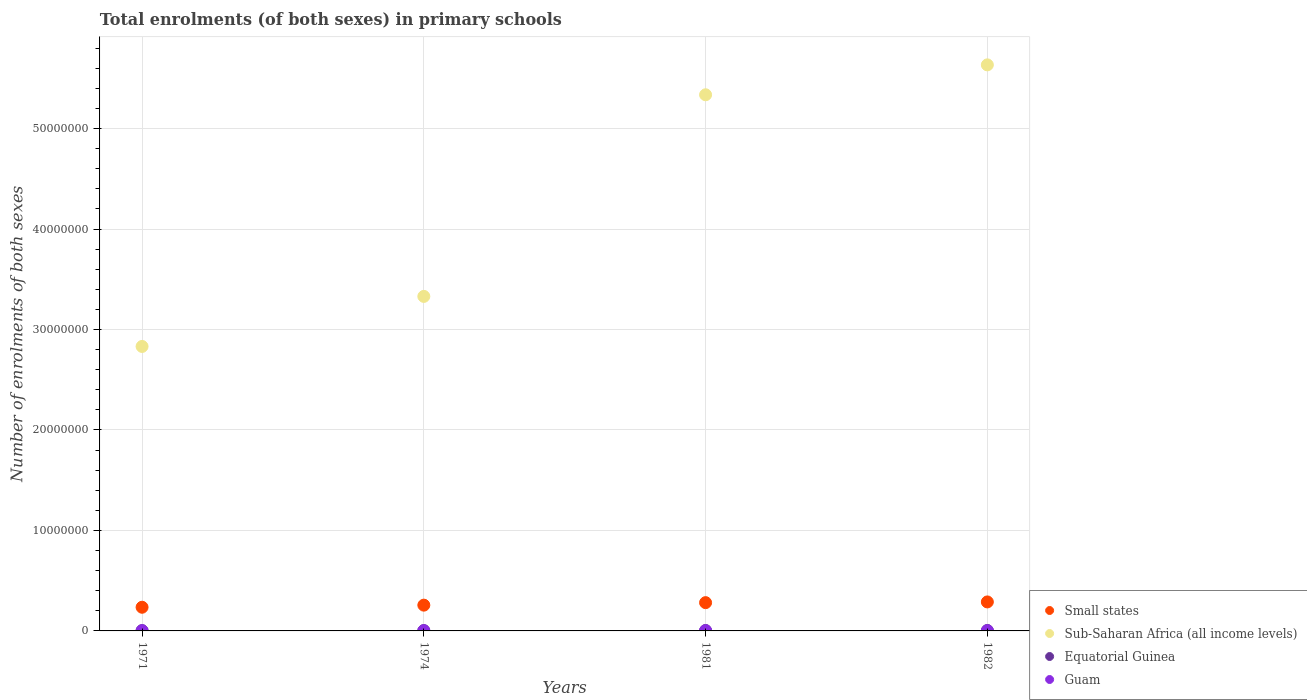How many different coloured dotlines are there?
Offer a terse response. 4. What is the number of enrolments in primary schools in Equatorial Guinea in 1971?
Your answer should be compact. 3.16e+04. Across all years, what is the maximum number of enrolments in primary schools in Guam?
Your answer should be compact. 1.85e+04. Across all years, what is the minimum number of enrolments in primary schools in Small states?
Offer a very short reply. 2.36e+06. In which year was the number of enrolments in primary schools in Equatorial Guinea maximum?
Provide a short and direct response. 1982. In which year was the number of enrolments in primary schools in Small states minimum?
Offer a very short reply. 1971. What is the total number of enrolments in primary schools in Small states in the graph?
Offer a very short reply. 1.06e+07. What is the difference between the number of enrolments in primary schools in Small states in 1971 and that in 1981?
Your response must be concise. -4.58e+05. What is the difference between the number of enrolments in primary schools in Sub-Saharan Africa (all income levels) in 1971 and the number of enrolments in primary schools in Guam in 1981?
Your answer should be compact. 2.83e+07. What is the average number of enrolments in primary schools in Sub-Saharan Africa (all income levels) per year?
Make the answer very short. 4.28e+07. In the year 1981, what is the difference between the number of enrolments in primary schools in Guam and number of enrolments in primary schools in Sub-Saharan Africa (all income levels)?
Ensure brevity in your answer.  -5.33e+07. In how many years, is the number of enrolments in primary schools in Sub-Saharan Africa (all income levels) greater than 22000000?
Your answer should be compact. 4. What is the ratio of the number of enrolments in primary schools in Equatorial Guinea in 1971 to that in 1981?
Keep it short and to the point. 0.71. Is the number of enrolments in primary schools in Guam in 1971 less than that in 1974?
Your answer should be very brief. Yes. Is the difference between the number of enrolments in primary schools in Guam in 1981 and 1982 greater than the difference between the number of enrolments in primary schools in Sub-Saharan Africa (all income levels) in 1981 and 1982?
Provide a succinct answer. Yes. What is the difference between the highest and the second highest number of enrolments in primary schools in Sub-Saharan Africa (all income levels)?
Your response must be concise. 2.98e+06. What is the difference between the highest and the lowest number of enrolments in primary schools in Small states?
Keep it short and to the point. 5.30e+05. Is the sum of the number of enrolments in primary schools in Equatorial Guinea in 1971 and 1982 greater than the maximum number of enrolments in primary schools in Small states across all years?
Keep it short and to the point. No. Is it the case that in every year, the sum of the number of enrolments in primary schools in Guam and number of enrolments in primary schools in Equatorial Guinea  is greater than the sum of number of enrolments in primary schools in Small states and number of enrolments in primary schools in Sub-Saharan Africa (all income levels)?
Ensure brevity in your answer.  No. Is it the case that in every year, the sum of the number of enrolments in primary schools in Sub-Saharan Africa (all income levels) and number of enrolments in primary schools in Equatorial Guinea  is greater than the number of enrolments in primary schools in Guam?
Your answer should be compact. Yes. Does the number of enrolments in primary schools in Guam monotonically increase over the years?
Keep it short and to the point. No. How many dotlines are there?
Offer a terse response. 4. How many years are there in the graph?
Your answer should be very brief. 4. Are the values on the major ticks of Y-axis written in scientific E-notation?
Provide a short and direct response. No. Where does the legend appear in the graph?
Give a very brief answer. Bottom right. What is the title of the graph?
Your answer should be very brief. Total enrolments (of both sexes) in primary schools. What is the label or title of the Y-axis?
Your answer should be very brief. Number of enrolments of both sexes. What is the Number of enrolments of both sexes in Small states in 1971?
Offer a very short reply. 2.36e+06. What is the Number of enrolments of both sexes in Sub-Saharan Africa (all income levels) in 1971?
Keep it short and to the point. 2.83e+07. What is the Number of enrolments of both sexes of Equatorial Guinea in 1971?
Provide a succinct answer. 3.16e+04. What is the Number of enrolments of both sexes in Guam in 1971?
Your answer should be compact. 1.79e+04. What is the Number of enrolments of both sexes of Small states in 1974?
Provide a succinct answer. 2.57e+06. What is the Number of enrolments of both sexes in Sub-Saharan Africa (all income levels) in 1974?
Provide a short and direct response. 3.33e+07. What is the Number of enrolments of both sexes in Equatorial Guinea in 1974?
Offer a terse response. 3.60e+04. What is the Number of enrolments of both sexes in Guam in 1974?
Offer a terse response. 1.85e+04. What is the Number of enrolments of both sexes of Small states in 1981?
Keep it short and to the point. 2.81e+06. What is the Number of enrolments of both sexes of Sub-Saharan Africa (all income levels) in 1981?
Your answer should be very brief. 5.34e+07. What is the Number of enrolments of both sexes in Equatorial Guinea in 1981?
Give a very brief answer. 4.45e+04. What is the Number of enrolments of both sexes of Guam in 1981?
Offer a terse response. 1.81e+04. What is the Number of enrolments of both sexes in Small states in 1982?
Your response must be concise. 2.89e+06. What is the Number of enrolments of both sexes of Sub-Saharan Africa (all income levels) in 1982?
Offer a terse response. 5.63e+07. What is the Number of enrolments of both sexes of Equatorial Guinea in 1982?
Your response must be concise. 4.54e+04. What is the Number of enrolments of both sexes in Guam in 1982?
Provide a short and direct response. 1.79e+04. Across all years, what is the maximum Number of enrolments of both sexes of Small states?
Give a very brief answer. 2.89e+06. Across all years, what is the maximum Number of enrolments of both sexes of Sub-Saharan Africa (all income levels)?
Your answer should be compact. 5.63e+07. Across all years, what is the maximum Number of enrolments of both sexes in Equatorial Guinea?
Give a very brief answer. 4.54e+04. Across all years, what is the maximum Number of enrolments of both sexes in Guam?
Your answer should be very brief. 1.85e+04. Across all years, what is the minimum Number of enrolments of both sexes of Small states?
Provide a succinct answer. 2.36e+06. Across all years, what is the minimum Number of enrolments of both sexes of Sub-Saharan Africa (all income levels)?
Offer a terse response. 2.83e+07. Across all years, what is the minimum Number of enrolments of both sexes in Equatorial Guinea?
Give a very brief answer. 3.16e+04. Across all years, what is the minimum Number of enrolments of both sexes of Guam?
Provide a succinct answer. 1.79e+04. What is the total Number of enrolments of both sexes in Small states in the graph?
Offer a terse response. 1.06e+07. What is the total Number of enrolments of both sexes of Sub-Saharan Africa (all income levels) in the graph?
Offer a terse response. 1.71e+08. What is the total Number of enrolments of both sexes of Equatorial Guinea in the graph?
Your answer should be very brief. 1.58e+05. What is the total Number of enrolments of both sexes of Guam in the graph?
Your answer should be very brief. 7.24e+04. What is the difference between the Number of enrolments of both sexes of Small states in 1971 and that in 1974?
Give a very brief answer. -2.10e+05. What is the difference between the Number of enrolments of both sexes of Sub-Saharan Africa (all income levels) in 1971 and that in 1974?
Provide a short and direct response. -4.98e+06. What is the difference between the Number of enrolments of both sexes of Equatorial Guinea in 1971 and that in 1974?
Your answer should be very brief. -4377. What is the difference between the Number of enrolments of both sexes of Guam in 1971 and that in 1974?
Your answer should be compact. -550. What is the difference between the Number of enrolments of both sexes of Small states in 1971 and that in 1981?
Give a very brief answer. -4.58e+05. What is the difference between the Number of enrolments of both sexes in Sub-Saharan Africa (all income levels) in 1971 and that in 1981?
Offer a very short reply. -2.50e+07. What is the difference between the Number of enrolments of both sexes of Equatorial Guinea in 1971 and that in 1981?
Ensure brevity in your answer.  -1.29e+04. What is the difference between the Number of enrolments of both sexes in Guam in 1971 and that in 1981?
Offer a very short reply. -166. What is the difference between the Number of enrolments of both sexes in Small states in 1971 and that in 1982?
Your response must be concise. -5.30e+05. What is the difference between the Number of enrolments of both sexes in Sub-Saharan Africa (all income levels) in 1971 and that in 1982?
Ensure brevity in your answer.  -2.80e+07. What is the difference between the Number of enrolments of both sexes of Equatorial Guinea in 1971 and that in 1982?
Offer a terse response. -1.38e+04. What is the difference between the Number of enrolments of both sexes in Guam in 1971 and that in 1982?
Offer a very short reply. -18. What is the difference between the Number of enrolments of both sexes in Small states in 1974 and that in 1981?
Provide a succinct answer. -2.49e+05. What is the difference between the Number of enrolments of both sexes in Sub-Saharan Africa (all income levels) in 1974 and that in 1981?
Ensure brevity in your answer.  -2.01e+07. What is the difference between the Number of enrolments of both sexes of Equatorial Guinea in 1974 and that in 1981?
Your response must be concise. -8522. What is the difference between the Number of enrolments of both sexes of Guam in 1974 and that in 1981?
Provide a short and direct response. 384. What is the difference between the Number of enrolments of both sexes in Small states in 1974 and that in 1982?
Give a very brief answer. -3.20e+05. What is the difference between the Number of enrolments of both sexes of Sub-Saharan Africa (all income levels) in 1974 and that in 1982?
Keep it short and to the point. -2.30e+07. What is the difference between the Number of enrolments of both sexes in Equatorial Guinea in 1974 and that in 1982?
Provide a short and direct response. -9451. What is the difference between the Number of enrolments of both sexes in Guam in 1974 and that in 1982?
Give a very brief answer. 532. What is the difference between the Number of enrolments of both sexes in Small states in 1981 and that in 1982?
Make the answer very short. -7.16e+04. What is the difference between the Number of enrolments of both sexes in Sub-Saharan Africa (all income levels) in 1981 and that in 1982?
Offer a very short reply. -2.98e+06. What is the difference between the Number of enrolments of both sexes of Equatorial Guinea in 1981 and that in 1982?
Ensure brevity in your answer.  -929. What is the difference between the Number of enrolments of both sexes of Guam in 1981 and that in 1982?
Make the answer very short. 148. What is the difference between the Number of enrolments of both sexes in Small states in 1971 and the Number of enrolments of both sexes in Sub-Saharan Africa (all income levels) in 1974?
Your answer should be compact. -3.09e+07. What is the difference between the Number of enrolments of both sexes of Small states in 1971 and the Number of enrolments of both sexes of Equatorial Guinea in 1974?
Make the answer very short. 2.32e+06. What is the difference between the Number of enrolments of both sexes of Small states in 1971 and the Number of enrolments of both sexes of Guam in 1974?
Provide a short and direct response. 2.34e+06. What is the difference between the Number of enrolments of both sexes of Sub-Saharan Africa (all income levels) in 1971 and the Number of enrolments of both sexes of Equatorial Guinea in 1974?
Provide a short and direct response. 2.83e+07. What is the difference between the Number of enrolments of both sexes in Sub-Saharan Africa (all income levels) in 1971 and the Number of enrolments of both sexes in Guam in 1974?
Keep it short and to the point. 2.83e+07. What is the difference between the Number of enrolments of both sexes of Equatorial Guinea in 1971 and the Number of enrolments of both sexes of Guam in 1974?
Your response must be concise. 1.31e+04. What is the difference between the Number of enrolments of both sexes of Small states in 1971 and the Number of enrolments of both sexes of Sub-Saharan Africa (all income levels) in 1981?
Offer a very short reply. -5.10e+07. What is the difference between the Number of enrolments of both sexes in Small states in 1971 and the Number of enrolments of both sexes in Equatorial Guinea in 1981?
Your answer should be very brief. 2.31e+06. What is the difference between the Number of enrolments of both sexes in Small states in 1971 and the Number of enrolments of both sexes in Guam in 1981?
Give a very brief answer. 2.34e+06. What is the difference between the Number of enrolments of both sexes of Sub-Saharan Africa (all income levels) in 1971 and the Number of enrolments of both sexes of Equatorial Guinea in 1981?
Offer a very short reply. 2.83e+07. What is the difference between the Number of enrolments of both sexes of Sub-Saharan Africa (all income levels) in 1971 and the Number of enrolments of both sexes of Guam in 1981?
Offer a very short reply. 2.83e+07. What is the difference between the Number of enrolments of both sexes in Equatorial Guinea in 1971 and the Number of enrolments of both sexes in Guam in 1981?
Your response must be concise. 1.35e+04. What is the difference between the Number of enrolments of both sexes in Small states in 1971 and the Number of enrolments of both sexes in Sub-Saharan Africa (all income levels) in 1982?
Offer a very short reply. -5.40e+07. What is the difference between the Number of enrolments of both sexes in Small states in 1971 and the Number of enrolments of both sexes in Equatorial Guinea in 1982?
Make the answer very short. 2.31e+06. What is the difference between the Number of enrolments of both sexes of Small states in 1971 and the Number of enrolments of both sexes of Guam in 1982?
Offer a very short reply. 2.34e+06. What is the difference between the Number of enrolments of both sexes of Sub-Saharan Africa (all income levels) in 1971 and the Number of enrolments of both sexes of Equatorial Guinea in 1982?
Make the answer very short. 2.83e+07. What is the difference between the Number of enrolments of both sexes in Sub-Saharan Africa (all income levels) in 1971 and the Number of enrolments of both sexes in Guam in 1982?
Keep it short and to the point. 2.83e+07. What is the difference between the Number of enrolments of both sexes in Equatorial Guinea in 1971 and the Number of enrolments of both sexes in Guam in 1982?
Provide a succinct answer. 1.37e+04. What is the difference between the Number of enrolments of both sexes in Small states in 1974 and the Number of enrolments of both sexes in Sub-Saharan Africa (all income levels) in 1981?
Give a very brief answer. -5.08e+07. What is the difference between the Number of enrolments of both sexes in Small states in 1974 and the Number of enrolments of both sexes in Equatorial Guinea in 1981?
Offer a terse response. 2.52e+06. What is the difference between the Number of enrolments of both sexes of Small states in 1974 and the Number of enrolments of both sexes of Guam in 1981?
Keep it short and to the point. 2.55e+06. What is the difference between the Number of enrolments of both sexes of Sub-Saharan Africa (all income levels) in 1974 and the Number of enrolments of both sexes of Equatorial Guinea in 1981?
Give a very brief answer. 3.33e+07. What is the difference between the Number of enrolments of both sexes of Sub-Saharan Africa (all income levels) in 1974 and the Number of enrolments of both sexes of Guam in 1981?
Make the answer very short. 3.33e+07. What is the difference between the Number of enrolments of both sexes of Equatorial Guinea in 1974 and the Number of enrolments of both sexes of Guam in 1981?
Give a very brief answer. 1.79e+04. What is the difference between the Number of enrolments of both sexes in Small states in 1974 and the Number of enrolments of both sexes in Sub-Saharan Africa (all income levels) in 1982?
Provide a short and direct response. -5.38e+07. What is the difference between the Number of enrolments of both sexes of Small states in 1974 and the Number of enrolments of both sexes of Equatorial Guinea in 1982?
Your response must be concise. 2.52e+06. What is the difference between the Number of enrolments of both sexes of Small states in 1974 and the Number of enrolments of both sexes of Guam in 1982?
Your response must be concise. 2.55e+06. What is the difference between the Number of enrolments of both sexes in Sub-Saharan Africa (all income levels) in 1974 and the Number of enrolments of both sexes in Equatorial Guinea in 1982?
Offer a very short reply. 3.32e+07. What is the difference between the Number of enrolments of both sexes in Sub-Saharan Africa (all income levels) in 1974 and the Number of enrolments of both sexes in Guam in 1982?
Make the answer very short. 3.33e+07. What is the difference between the Number of enrolments of both sexes of Equatorial Guinea in 1974 and the Number of enrolments of both sexes of Guam in 1982?
Ensure brevity in your answer.  1.80e+04. What is the difference between the Number of enrolments of both sexes of Small states in 1981 and the Number of enrolments of both sexes of Sub-Saharan Africa (all income levels) in 1982?
Offer a terse response. -5.35e+07. What is the difference between the Number of enrolments of both sexes of Small states in 1981 and the Number of enrolments of both sexes of Equatorial Guinea in 1982?
Ensure brevity in your answer.  2.77e+06. What is the difference between the Number of enrolments of both sexes in Small states in 1981 and the Number of enrolments of both sexes in Guam in 1982?
Keep it short and to the point. 2.80e+06. What is the difference between the Number of enrolments of both sexes of Sub-Saharan Africa (all income levels) in 1981 and the Number of enrolments of both sexes of Equatorial Guinea in 1982?
Give a very brief answer. 5.33e+07. What is the difference between the Number of enrolments of both sexes in Sub-Saharan Africa (all income levels) in 1981 and the Number of enrolments of both sexes in Guam in 1982?
Your answer should be compact. 5.33e+07. What is the difference between the Number of enrolments of both sexes in Equatorial Guinea in 1981 and the Number of enrolments of both sexes in Guam in 1982?
Your answer should be compact. 2.66e+04. What is the average Number of enrolments of both sexes of Small states per year?
Offer a terse response. 2.66e+06. What is the average Number of enrolments of both sexes of Sub-Saharan Africa (all income levels) per year?
Give a very brief answer. 4.28e+07. What is the average Number of enrolments of both sexes in Equatorial Guinea per year?
Offer a very short reply. 3.94e+04. What is the average Number of enrolments of both sexes of Guam per year?
Keep it short and to the point. 1.81e+04. In the year 1971, what is the difference between the Number of enrolments of both sexes in Small states and Number of enrolments of both sexes in Sub-Saharan Africa (all income levels)?
Give a very brief answer. -2.60e+07. In the year 1971, what is the difference between the Number of enrolments of both sexes in Small states and Number of enrolments of both sexes in Equatorial Guinea?
Give a very brief answer. 2.32e+06. In the year 1971, what is the difference between the Number of enrolments of both sexes in Small states and Number of enrolments of both sexes in Guam?
Your response must be concise. 2.34e+06. In the year 1971, what is the difference between the Number of enrolments of both sexes in Sub-Saharan Africa (all income levels) and Number of enrolments of both sexes in Equatorial Guinea?
Provide a short and direct response. 2.83e+07. In the year 1971, what is the difference between the Number of enrolments of both sexes in Sub-Saharan Africa (all income levels) and Number of enrolments of both sexes in Guam?
Your response must be concise. 2.83e+07. In the year 1971, what is the difference between the Number of enrolments of both sexes of Equatorial Guinea and Number of enrolments of both sexes of Guam?
Your answer should be compact. 1.37e+04. In the year 1974, what is the difference between the Number of enrolments of both sexes of Small states and Number of enrolments of both sexes of Sub-Saharan Africa (all income levels)?
Offer a very short reply. -3.07e+07. In the year 1974, what is the difference between the Number of enrolments of both sexes of Small states and Number of enrolments of both sexes of Equatorial Guinea?
Give a very brief answer. 2.53e+06. In the year 1974, what is the difference between the Number of enrolments of both sexes in Small states and Number of enrolments of both sexes in Guam?
Your answer should be very brief. 2.55e+06. In the year 1974, what is the difference between the Number of enrolments of both sexes of Sub-Saharan Africa (all income levels) and Number of enrolments of both sexes of Equatorial Guinea?
Your answer should be compact. 3.33e+07. In the year 1974, what is the difference between the Number of enrolments of both sexes in Sub-Saharan Africa (all income levels) and Number of enrolments of both sexes in Guam?
Offer a terse response. 3.33e+07. In the year 1974, what is the difference between the Number of enrolments of both sexes in Equatorial Guinea and Number of enrolments of both sexes in Guam?
Your response must be concise. 1.75e+04. In the year 1981, what is the difference between the Number of enrolments of both sexes in Small states and Number of enrolments of both sexes in Sub-Saharan Africa (all income levels)?
Your answer should be very brief. -5.05e+07. In the year 1981, what is the difference between the Number of enrolments of both sexes in Small states and Number of enrolments of both sexes in Equatorial Guinea?
Offer a very short reply. 2.77e+06. In the year 1981, what is the difference between the Number of enrolments of both sexes of Small states and Number of enrolments of both sexes of Guam?
Ensure brevity in your answer.  2.80e+06. In the year 1981, what is the difference between the Number of enrolments of both sexes of Sub-Saharan Africa (all income levels) and Number of enrolments of both sexes of Equatorial Guinea?
Your answer should be very brief. 5.33e+07. In the year 1981, what is the difference between the Number of enrolments of both sexes in Sub-Saharan Africa (all income levels) and Number of enrolments of both sexes in Guam?
Give a very brief answer. 5.33e+07. In the year 1981, what is the difference between the Number of enrolments of both sexes in Equatorial Guinea and Number of enrolments of both sexes in Guam?
Ensure brevity in your answer.  2.64e+04. In the year 1982, what is the difference between the Number of enrolments of both sexes of Small states and Number of enrolments of both sexes of Sub-Saharan Africa (all income levels)?
Make the answer very short. -5.35e+07. In the year 1982, what is the difference between the Number of enrolments of both sexes in Small states and Number of enrolments of both sexes in Equatorial Guinea?
Ensure brevity in your answer.  2.84e+06. In the year 1982, what is the difference between the Number of enrolments of both sexes of Small states and Number of enrolments of both sexes of Guam?
Make the answer very short. 2.87e+06. In the year 1982, what is the difference between the Number of enrolments of both sexes in Sub-Saharan Africa (all income levels) and Number of enrolments of both sexes in Equatorial Guinea?
Provide a short and direct response. 5.63e+07. In the year 1982, what is the difference between the Number of enrolments of both sexes in Sub-Saharan Africa (all income levels) and Number of enrolments of both sexes in Guam?
Ensure brevity in your answer.  5.63e+07. In the year 1982, what is the difference between the Number of enrolments of both sexes of Equatorial Guinea and Number of enrolments of both sexes of Guam?
Ensure brevity in your answer.  2.75e+04. What is the ratio of the Number of enrolments of both sexes of Small states in 1971 to that in 1974?
Offer a very short reply. 0.92. What is the ratio of the Number of enrolments of both sexes in Sub-Saharan Africa (all income levels) in 1971 to that in 1974?
Your answer should be very brief. 0.85. What is the ratio of the Number of enrolments of both sexes in Equatorial Guinea in 1971 to that in 1974?
Make the answer very short. 0.88. What is the ratio of the Number of enrolments of both sexes in Guam in 1971 to that in 1974?
Offer a very short reply. 0.97. What is the ratio of the Number of enrolments of both sexes in Small states in 1971 to that in 1981?
Your answer should be very brief. 0.84. What is the ratio of the Number of enrolments of both sexes in Sub-Saharan Africa (all income levels) in 1971 to that in 1981?
Provide a succinct answer. 0.53. What is the ratio of the Number of enrolments of both sexes of Equatorial Guinea in 1971 to that in 1981?
Your answer should be compact. 0.71. What is the ratio of the Number of enrolments of both sexes of Small states in 1971 to that in 1982?
Your answer should be compact. 0.82. What is the ratio of the Number of enrolments of both sexes of Sub-Saharan Africa (all income levels) in 1971 to that in 1982?
Provide a short and direct response. 0.5. What is the ratio of the Number of enrolments of both sexes of Equatorial Guinea in 1971 to that in 1982?
Your response must be concise. 0.7. What is the ratio of the Number of enrolments of both sexes in Guam in 1971 to that in 1982?
Provide a short and direct response. 1. What is the ratio of the Number of enrolments of both sexes of Small states in 1974 to that in 1981?
Ensure brevity in your answer.  0.91. What is the ratio of the Number of enrolments of both sexes of Sub-Saharan Africa (all income levels) in 1974 to that in 1981?
Your answer should be very brief. 0.62. What is the ratio of the Number of enrolments of both sexes in Equatorial Guinea in 1974 to that in 1981?
Ensure brevity in your answer.  0.81. What is the ratio of the Number of enrolments of both sexes in Guam in 1974 to that in 1981?
Keep it short and to the point. 1.02. What is the ratio of the Number of enrolments of both sexes in Small states in 1974 to that in 1982?
Your answer should be very brief. 0.89. What is the ratio of the Number of enrolments of both sexes in Sub-Saharan Africa (all income levels) in 1974 to that in 1982?
Offer a terse response. 0.59. What is the ratio of the Number of enrolments of both sexes of Equatorial Guinea in 1974 to that in 1982?
Your answer should be very brief. 0.79. What is the ratio of the Number of enrolments of both sexes of Guam in 1974 to that in 1982?
Offer a very short reply. 1.03. What is the ratio of the Number of enrolments of both sexes of Small states in 1981 to that in 1982?
Make the answer very short. 0.98. What is the ratio of the Number of enrolments of both sexes of Sub-Saharan Africa (all income levels) in 1981 to that in 1982?
Your answer should be very brief. 0.95. What is the ratio of the Number of enrolments of both sexes of Equatorial Guinea in 1981 to that in 1982?
Make the answer very short. 0.98. What is the ratio of the Number of enrolments of both sexes in Guam in 1981 to that in 1982?
Provide a succinct answer. 1.01. What is the difference between the highest and the second highest Number of enrolments of both sexes of Small states?
Your answer should be very brief. 7.16e+04. What is the difference between the highest and the second highest Number of enrolments of both sexes in Sub-Saharan Africa (all income levels)?
Your response must be concise. 2.98e+06. What is the difference between the highest and the second highest Number of enrolments of both sexes in Equatorial Guinea?
Keep it short and to the point. 929. What is the difference between the highest and the second highest Number of enrolments of both sexes of Guam?
Provide a succinct answer. 384. What is the difference between the highest and the lowest Number of enrolments of both sexes in Small states?
Make the answer very short. 5.30e+05. What is the difference between the highest and the lowest Number of enrolments of both sexes of Sub-Saharan Africa (all income levels)?
Provide a succinct answer. 2.80e+07. What is the difference between the highest and the lowest Number of enrolments of both sexes in Equatorial Guinea?
Provide a short and direct response. 1.38e+04. What is the difference between the highest and the lowest Number of enrolments of both sexes in Guam?
Your answer should be compact. 550. 